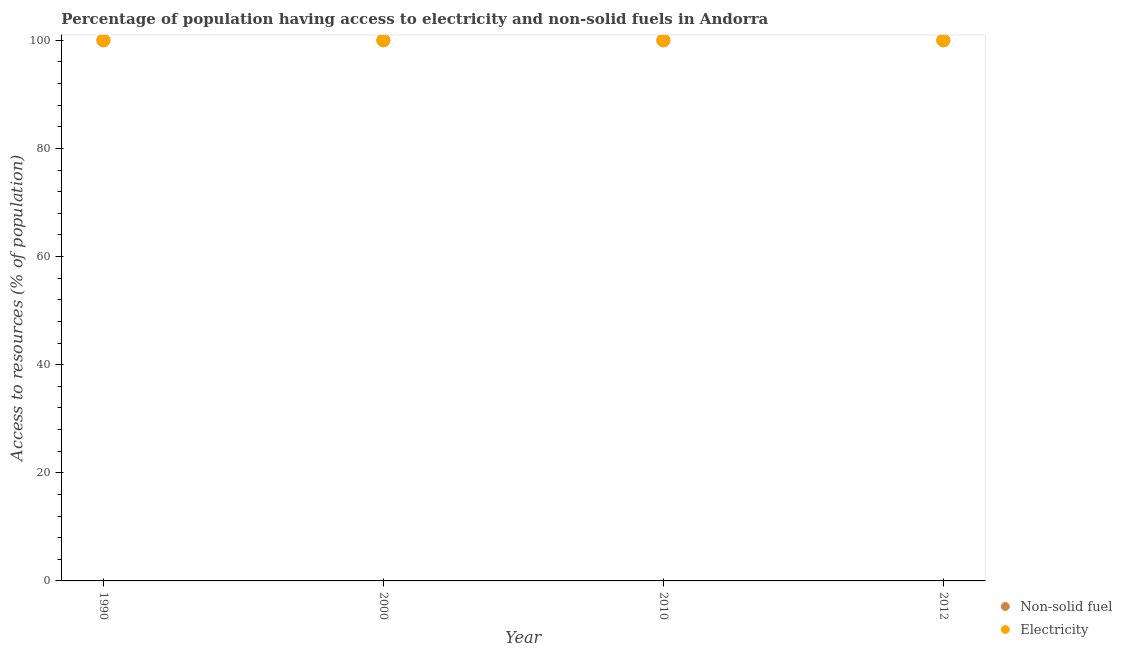What is the percentage of population having access to electricity in 2000?
Provide a succinct answer. 100. Across all years, what is the maximum percentage of population having access to electricity?
Your answer should be compact. 100. Across all years, what is the minimum percentage of population having access to non-solid fuel?
Provide a short and direct response. 100. In which year was the percentage of population having access to non-solid fuel maximum?
Ensure brevity in your answer.  1990. In which year was the percentage of population having access to electricity minimum?
Your answer should be compact. 1990. What is the total percentage of population having access to non-solid fuel in the graph?
Ensure brevity in your answer.  400. What is the difference between the percentage of population having access to electricity in 2010 and the percentage of population having access to non-solid fuel in 2012?
Provide a short and direct response. 0. What is the average percentage of population having access to electricity per year?
Offer a terse response. 100. In how many years, is the percentage of population having access to non-solid fuel greater than 84 %?
Your answer should be very brief. 4. What is the ratio of the percentage of population having access to non-solid fuel in 1990 to that in 2000?
Your answer should be compact. 1. Is the percentage of population having access to non-solid fuel in 1990 less than that in 2012?
Ensure brevity in your answer.  No. In how many years, is the percentage of population having access to non-solid fuel greater than the average percentage of population having access to non-solid fuel taken over all years?
Provide a succinct answer. 0. Is the percentage of population having access to non-solid fuel strictly greater than the percentage of population having access to electricity over the years?
Offer a very short reply. No. Is the percentage of population having access to electricity strictly less than the percentage of population having access to non-solid fuel over the years?
Provide a succinct answer. No. How many dotlines are there?
Your answer should be very brief. 2. How many years are there in the graph?
Offer a terse response. 4. Are the values on the major ticks of Y-axis written in scientific E-notation?
Offer a very short reply. No. Does the graph contain any zero values?
Your answer should be very brief. No. Does the graph contain grids?
Give a very brief answer. No. What is the title of the graph?
Your answer should be very brief. Percentage of population having access to electricity and non-solid fuels in Andorra. What is the label or title of the Y-axis?
Make the answer very short. Access to resources (% of population). What is the Access to resources (% of population) of Electricity in 1990?
Give a very brief answer. 100. What is the Access to resources (% of population) of Electricity in 2000?
Provide a short and direct response. 100. What is the Access to resources (% of population) of Non-solid fuel in 2012?
Give a very brief answer. 100. Across all years, what is the maximum Access to resources (% of population) of Non-solid fuel?
Your response must be concise. 100. Across all years, what is the minimum Access to resources (% of population) in Non-solid fuel?
Keep it short and to the point. 100. What is the total Access to resources (% of population) in Electricity in the graph?
Provide a short and direct response. 400. What is the difference between the Access to resources (% of population) of Non-solid fuel in 1990 and that in 2000?
Offer a terse response. 0. What is the difference between the Access to resources (% of population) in Non-solid fuel in 1990 and that in 2010?
Your answer should be very brief. 0. What is the difference between the Access to resources (% of population) of Electricity in 1990 and that in 2010?
Make the answer very short. 0. What is the difference between the Access to resources (% of population) in Non-solid fuel in 1990 and that in 2012?
Your answer should be compact. 0. What is the difference between the Access to resources (% of population) in Electricity in 2000 and that in 2010?
Your response must be concise. 0. What is the difference between the Access to resources (% of population) in Non-solid fuel in 2000 and that in 2012?
Provide a succinct answer. 0. What is the difference between the Access to resources (% of population) in Electricity in 2000 and that in 2012?
Give a very brief answer. 0. What is the difference between the Access to resources (% of population) of Non-solid fuel in 2010 and that in 2012?
Offer a very short reply. 0. What is the difference between the Access to resources (% of population) of Non-solid fuel in 1990 and the Access to resources (% of population) of Electricity in 2000?
Your answer should be compact. 0. What is the difference between the Access to resources (% of population) in Non-solid fuel in 1990 and the Access to resources (% of population) in Electricity in 2010?
Your answer should be very brief. 0. What is the difference between the Access to resources (% of population) in Non-solid fuel in 1990 and the Access to resources (% of population) in Electricity in 2012?
Keep it short and to the point. 0. What is the difference between the Access to resources (% of population) in Non-solid fuel in 2000 and the Access to resources (% of population) in Electricity in 2010?
Give a very brief answer. 0. What is the average Access to resources (% of population) of Non-solid fuel per year?
Your response must be concise. 100. What is the average Access to resources (% of population) in Electricity per year?
Provide a succinct answer. 100. In the year 2000, what is the difference between the Access to resources (% of population) in Non-solid fuel and Access to resources (% of population) in Electricity?
Ensure brevity in your answer.  0. What is the ratio of the Access to resources (% of population) of Non-solid fuel in 1990 to that in 2000?
Provide a short and direct response. 1. What is the ratio of the Access to resources (% of population) in Electricity in 1990 to that in 2010?
Provide a succinct answer. 1. What is the ratio of the Access to resources (% of population) of Non-solid fuel in 2000 to that in 2010?
Make the answer very short. 1. What is the ratio of the Access to resources (% of population) of Electricity in 2000 to that in 2010?
Your answer should be very brief. 1. What is the ratio of the Access to resources (% of population) in Non-solid fuel in 2000 to that in 2012?
Provide a short and direct response. 1. What is the ratio of the Access to resources (% of population) in Non-solid fuel in 2010 to that in 2012?
Your answer should be very brief. 1. What is the difference between the highest and the second highest Access to resources (% of population) of Non-solid fuel?
Offer a very short reply. 0. What is the difference between the highest and the second highest Access to resources (% of population) in Electricity?
Ensure brevity in your answer.  0. What is the difference between the highest and the lowest Access to resources (% of population) in Non-solid fuel?
Your response must be concise. 0. 